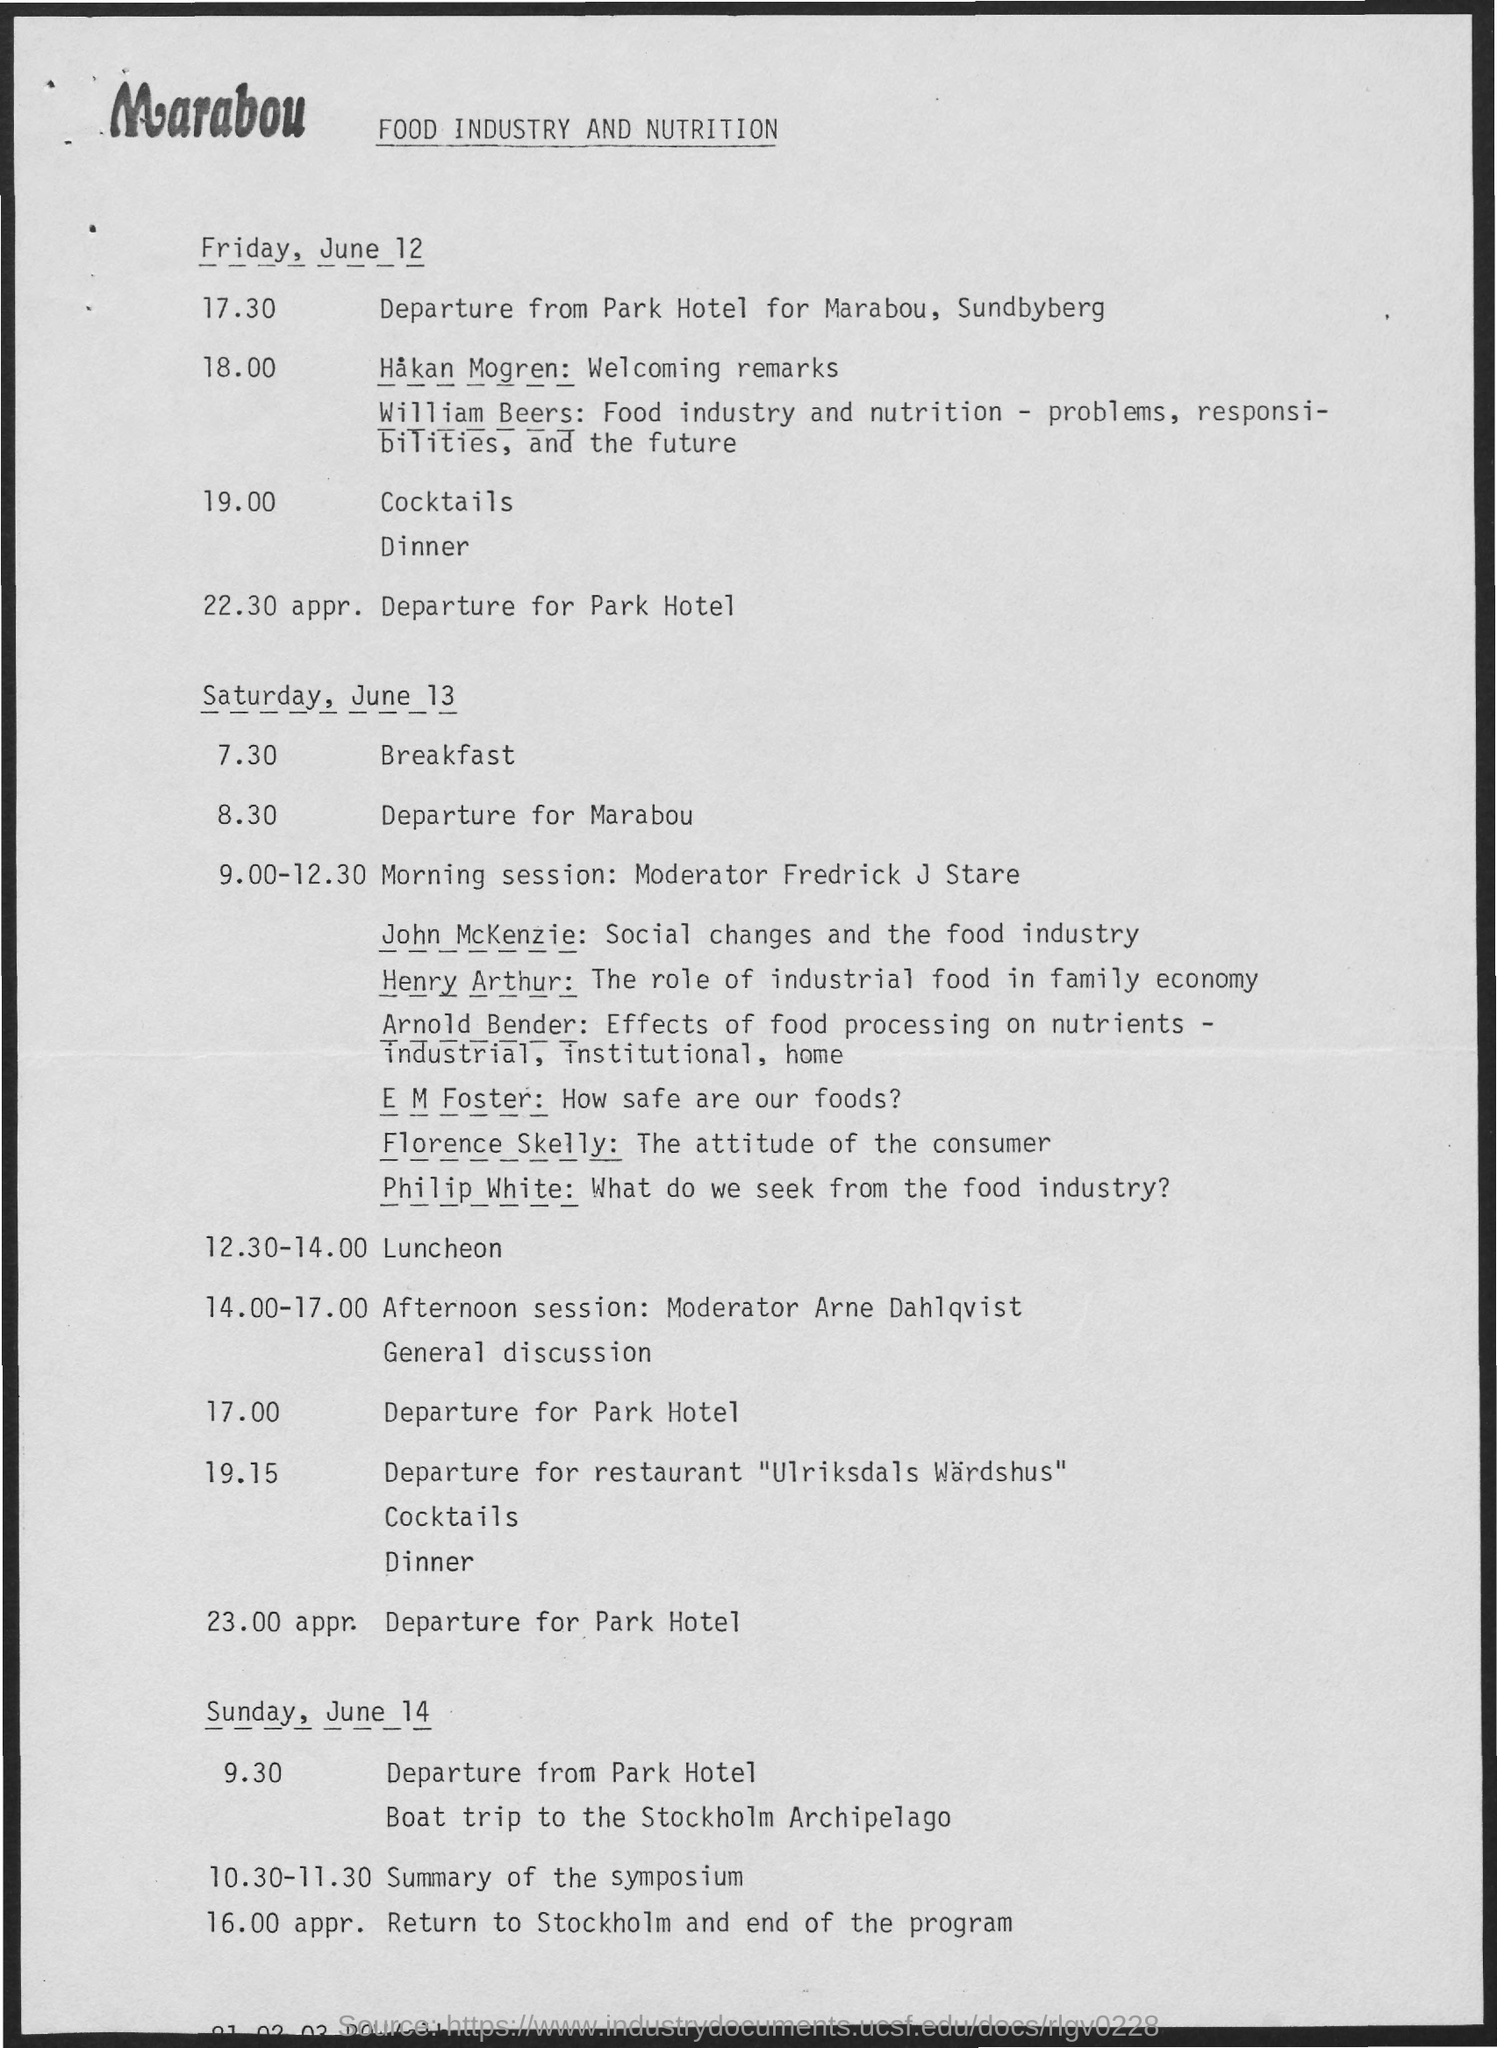When is the departure for park hotel on Friday, June 12 scheduled?
Offer a terse response. 22.30 appr. When is the summary of the symposium held on Sunday, June 14?
Offer a very short reply. 10.30-11.30. Which date is the return to Stockholm and the end of the program?
Ensure brevity in your answer.  Sunday, June 14. 